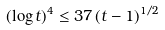<formula> <loc_0><loc_0><loc_500><loc_500>( \log t ) ^ { 4 } \leq 3 7 \, ( t - 1 ) ^ { 1 / 2 }</formula> 